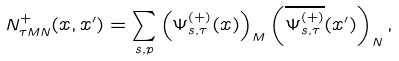Convert formula to latex. <formula><loc_0><loc_0><loc_500><loc_500>N ^ { + } _ { \tau M N } ( x , x ^ { \prime } ) = \sum _ { s , p } \left ( \Psi ^ { ( + ) } _ { s , \tau } ( x ) \right ) _ { M } \left ( \overline { \Psi ^ { ( + ) } _ { s , \tau } } ( x ^ { \prime } ) \right ) _ { N } ,</formula> 